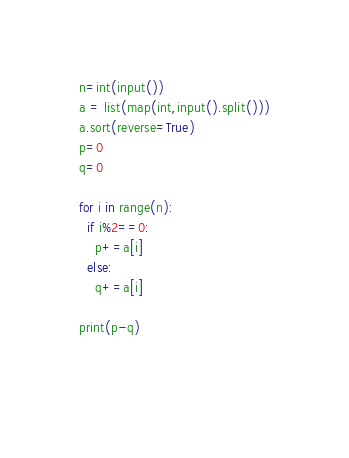<code> <loc_0><loc_0><loc_500><loc_500><_Python_>n=int(input())
a = list(map(int,input().split()))
a.sort(reverse=True)
p=0
q=0

for i in range(n):
  if i%2==0:
    p+=a[i]
  else:
    q+=a[i]
    
print(p-q)
      
    </code> 